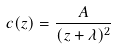<formula> <loc_0><loc_0><loc_500><loc_500>c ( z ) = \frac { A } { ( z + \lambda ) ^ { 2 } }</formula> 